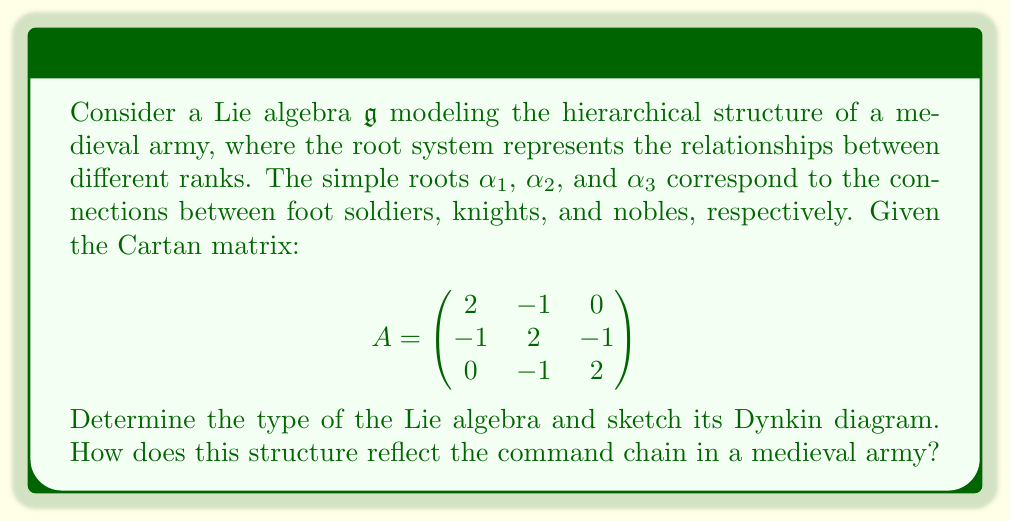Show me your answer to this math problem. To analyze the root system and determine the type of the Lie algebra, we follow these steps:

1. Examine the Cartan matrix:
   The given Cartan matrix $A$ is a 3x3 matrix, indicating that the Lie algebra has rank 3.

2. Identify the Lie algebra type:
   The structure of the Cartan matrix corresponds to the $A_3$ Lie algebra, which is isomorphic to $\mathfrak{sl}(4, \mathbb{C})$.

3. Construct the Dynkin diagram:
   - Each simple root corresponds to a node in the diagram.
   - The number of lines connecting two nodes is determined by the off-diagonal elements of the Cartan matrix.
   - For $A_3$, we have three nodes connected by single lines:

   [asy]
   unitsize(1cm);
   dot((0,0)); dot((1,0)); dot((2,0));
   draw((0,0)--(2,0));
   label("$\alpha_1$", (0,-0.5));
   label("$\alpha_2$", (1,-0.5));
   label("$\alpha_3$", (2,-0.5));
   [/asy]

4. Interpret the structure in the context of a medieval army:
   - $\alpha_1$ (foot soldiers): Connected only to $\alpha_2$, representing the direct command from knights.
   - $\alpha_2$ (knights): Connected to both $\alpha_1$ and $\alpha_3$, acting as intermediaries between foot soldiers and nobles.
   - $\alpha_3$ (nobles): Connected only to $\alpha_2$, indicating they command knights directly but not foot soldiers.

This structure reflects the typical command chain in a medieval army:
- Nobles at the top of the hierarchy (represented by $\alpha_3$)
- Knights in the middle, receiving orders from nobles and commanding foot soldiers (represented by $\alpha_2$)
- Foot soldiers at the bottom, taking orders from knights (represented by $\alpha_1$)

The Dynkin diagram visually represents these relationships, with each connection indicating a direct line of command or influence between ranks.
Answer: The Lie algebra is of type $A_3$, with the Dynkin diagram:

[asy]
unitsize(1cm);
dot((0,0)); dot((1,0)); dot((2,0));
draw((0,0)--(2,0));
label("$\alpha_1$", (0,-0.5));
label("$\alpha_2$", (1,-0.5));
label("$\alpha_3$", (2,-0.5));
[/asy]

This structure reflects the medieval army's command chain: nobles ($\alpha_3$) command knights ($\alpha_2$), who in turn command foot soldiers ($\alpha_1$), with each rank directly influencing only the adjacent rank in the hierarchy. 